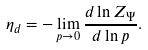Convert formula to latex. <formula><loc_0><loc_0><loc_500><loc_500>\eta _ { d } = - \lim _ { p \rightarrow 0 } \frac { d \ln Z _ { \Psi } } { d \ln p } .</formula> 